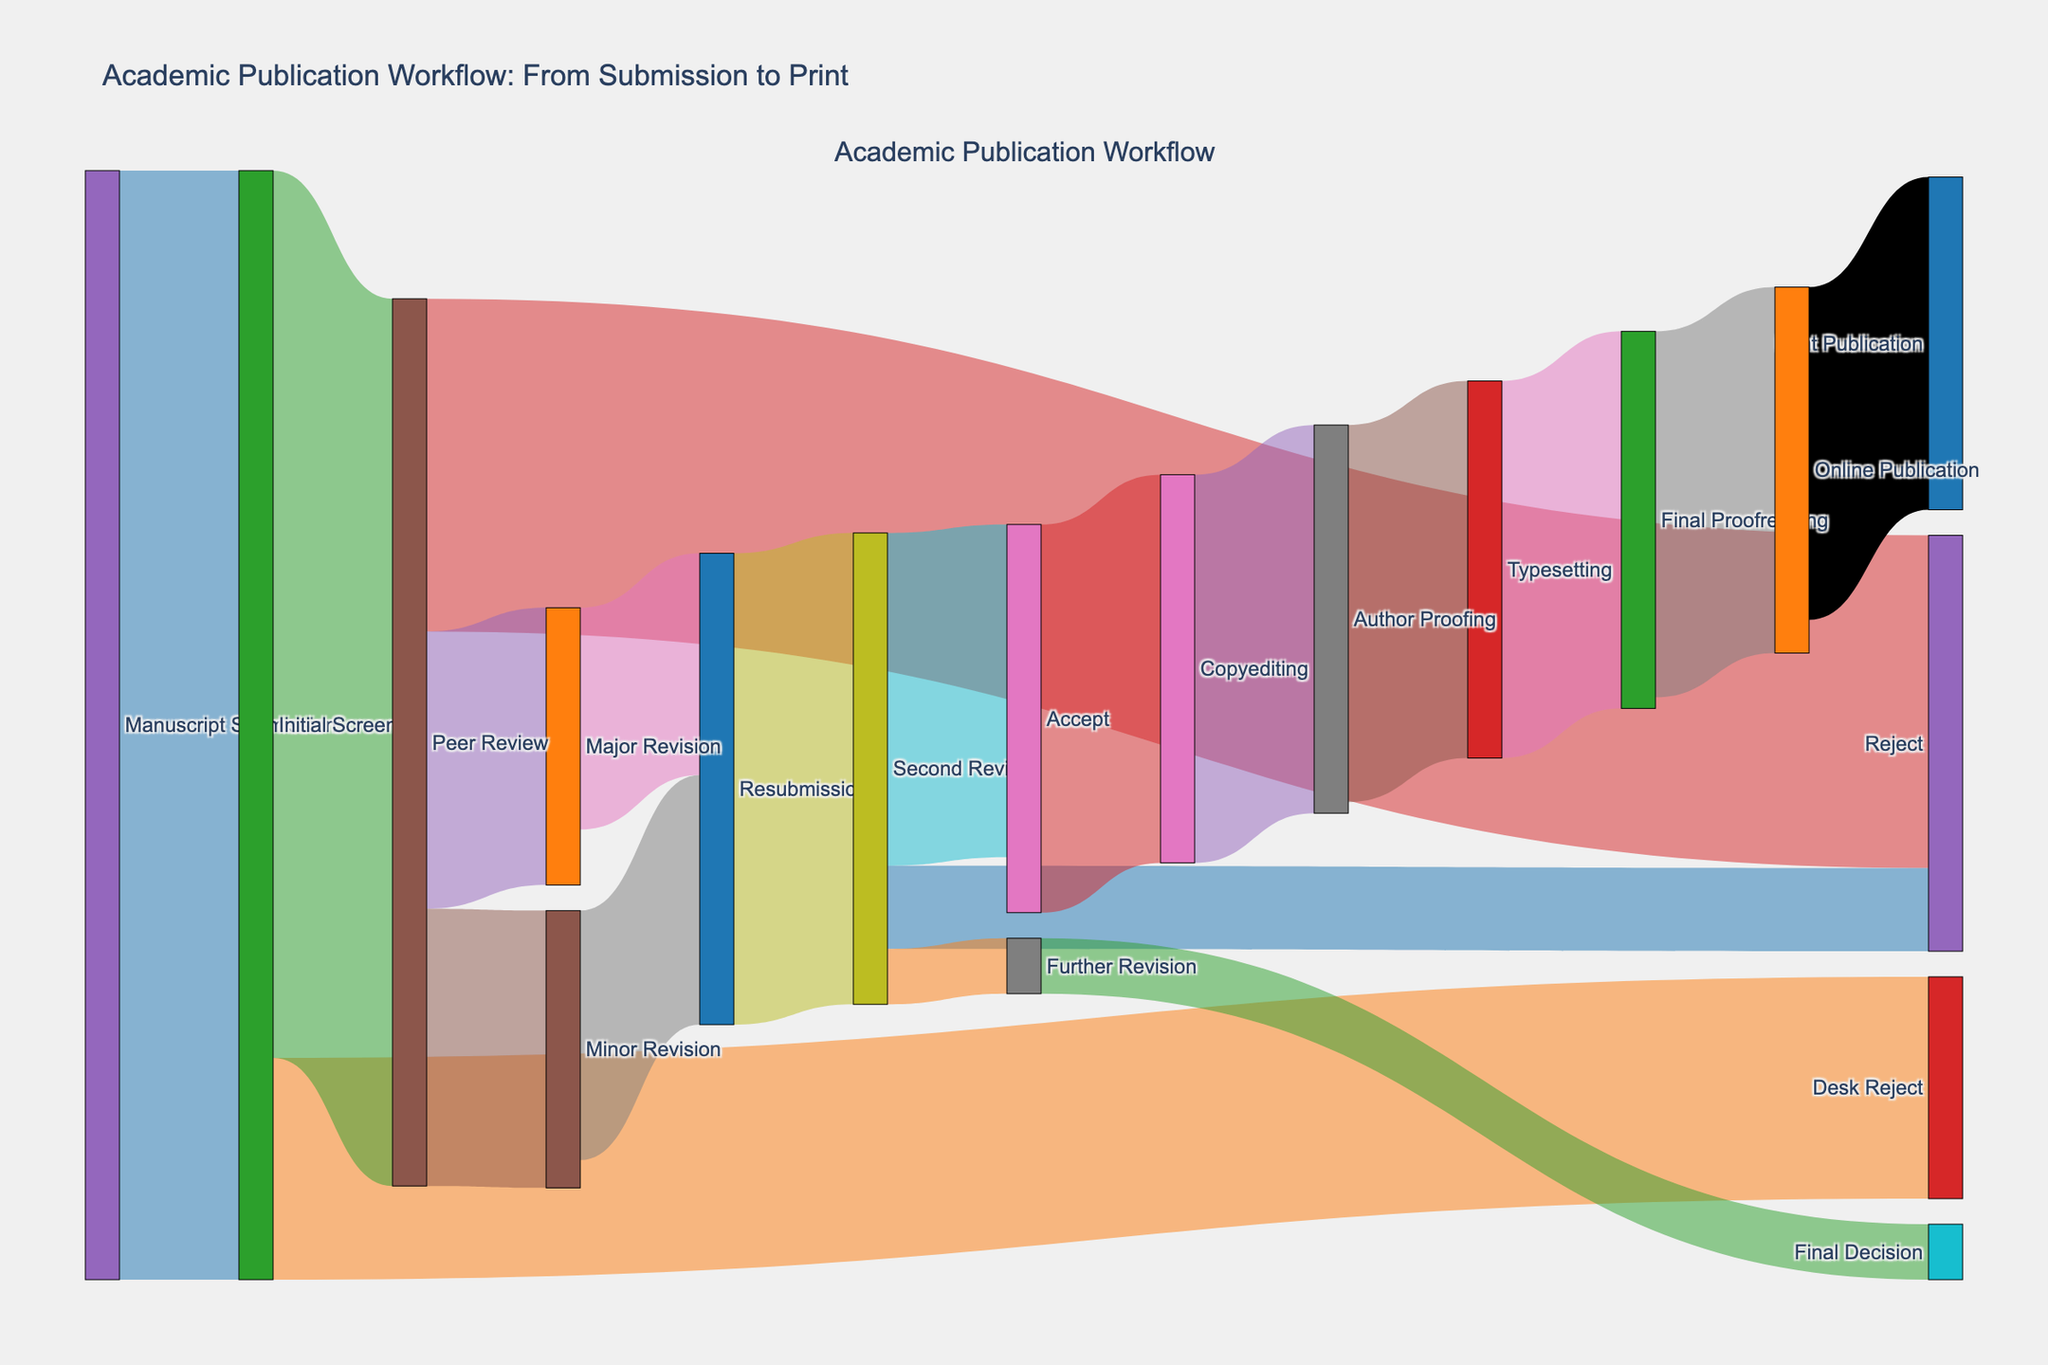What is the title of the Sankey diagram? The title is usually displayed at the top of the figure and provides a description of what the diagram represents.
Answer: Academic Publication Workflow: From Submission to Print How many manuscripts were submitted initially? The node labeled "Manuscript Submission" indicates the starting point and its corresponding value represents the total number of submissions.
Answer: 1000 What is the total number of manuscripts that were rejected at any stage? Count the values for "Desk Reject," "Reject" from Peer Review, and "Reject" from Second Review, then add them together: 200 (Desk Reject) + 300 (Peer Review) + 75 (Second Review) = 575.
Answer: 575 Which stage has the highest number of manuscripts progressing to the next step after "Initial Screening"? Compare the values between the targets "Desk Reject" and "Peer Review" from "Initial Screening". 800 manuscripts went to "Peer Review," which is higher than 200 that went to "Desk Reject."
Answer: Peer Review What is the difference in the number of manuscripts between the "Major Revision" and "Minor Revision" that proceeded to "Resubmission"? Identify the values associated with "Major Revision" to "Resubmission" and "Minor Revision" to "Resubmission" and compute the difference: 225 (Minor Revision to Resubmission) - 200 (Major Revision to Resubmission) = 25.
Answer: 25 How many manuscripts proceeded from "Final Proofreading" to "Online Publication"? The flow from "Final Proofreading" to "Online Publication" displays the transition and its corresponding value.
Answer: 330 Between "Copyediting" and "Author Proofing," which step has the same number of manuscripts moving to the next stage? Examine the values associated with the transitions from "Copyediting" to "Author Proofing" and from "Author Proofing" to "Typesetting". Both transitions have the value of 350.
Answer: Both have the same number (350) What is the ratio of manuscripts that reached "Print Publication" to the initially submitted manuscripts? The number of manuscripts that reached "Print Publication" is 300, and the initially submitted number is 1000. Calculate the ratio: 300 / 1000 = 0.3.
Answer: 0.3 How many manuscripts went through "Second Review" before being accepted for publication? Sum the value of manuscripts that moved to "Second Review": 300 (Accept) + 75 (Reject) + 50 (Further Revision) = 425.
Answer: 425 Identify the smallest transition value in the entire process. Look at all the transition values displayed and find the smallest number. The smallest value is in the "Further Revision" to "Final Decision" transition, which is 50.
Answer: 50 